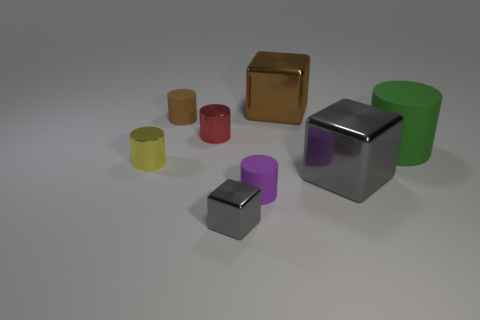Does the green matte object have the same shape as the yellow metal object?
Provide a succinct answer. Yes. Are there any other things that are the same color as the tiny metallic cube?
Make the answer very short. Yes. There is a object that is in front of the big green cylinder and behind the large gray metal block; what is its shape?
Provide a short and direct response. Cylinder. Is the number of gray shiny blocks to the left of the small brown cylinder the same as the number of tiny gray metal blocks that are to the left of the yellow metallic cylinder?
Provide a short and direct response. Yes. How many cylinders are tiny rubber objects or big brown shiny objects?
Make the answer very short. 2. How many cylinders have the same material as the tiny block?
Offer a terse response. 2. There is a metallic thing that is the same color as the small block; what is its shape?
Your answer should be compact. Cube. There is a cube that is both in front of the brown rubber cylinder and on the right side of the purple rubber thing; what is its material?
Offer a terse response. Metal. What is the shape of the brown thing in front of the brown metal cube?
Your response must be concise. Cylinder. There is a big green object that is behind the gray block right of the big brown metallic object; what shape is it?
Provide a short and direct response. Cylinder. 